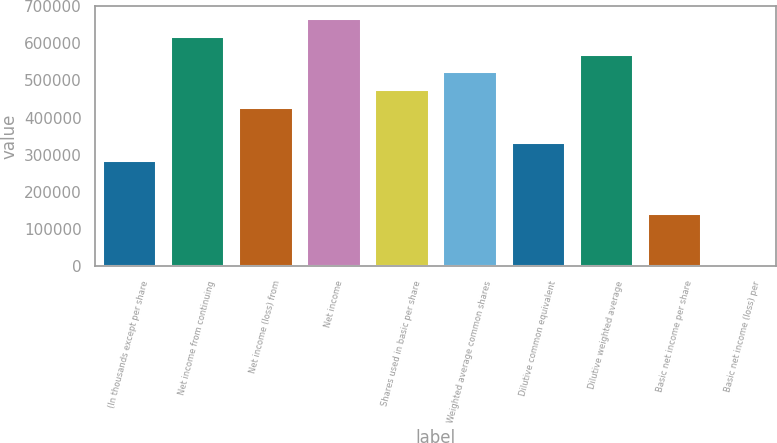Convert chart to OTSL. <chart><loc_0><loc_0><loc_500><loc_500><bar_chart><fcel>(In thousands except per share<fcel>Net income from continuing<fcel>Net income (loss) from<fcel>Net income<fcel>Shares used in basic per share<fcel>Weighted average common shares<fcel>Dilutive common equivalent<fcel>Dilutive weighted average<fcel>Basic net income per share<fcel>Basic net income (loss) per<nl><fcel>286057<fcel>619791<fcel>429086<fcel>667467<fcel>476762<fcel>524438<fcel>333733<fcel>572114<fcel>143029<fcel>0.08<nl></chart> 